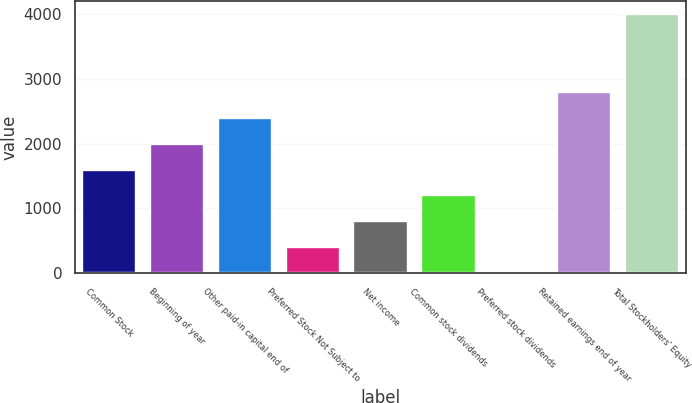<chart> <loc_0><loc_0><loc_500><loc_500><bar_chart><fcel>Common Stock<fcel>Beginning of year<fcel>Other paid-in capital end of<fcel>Preferred Stock Not Subject to<fcel>Net income<fcel>Common stock dividends<fcel>Preferred stock dividends<fcel>Retained earnings end of year<fcel>Total Stockholders' Equity<nl><fcel>1599<fcel>1998<fcel>2397<fcel>402<fcel>801<fcel>1200<fcel>3<fcel>2796<fcel>3993<nl></chart> 